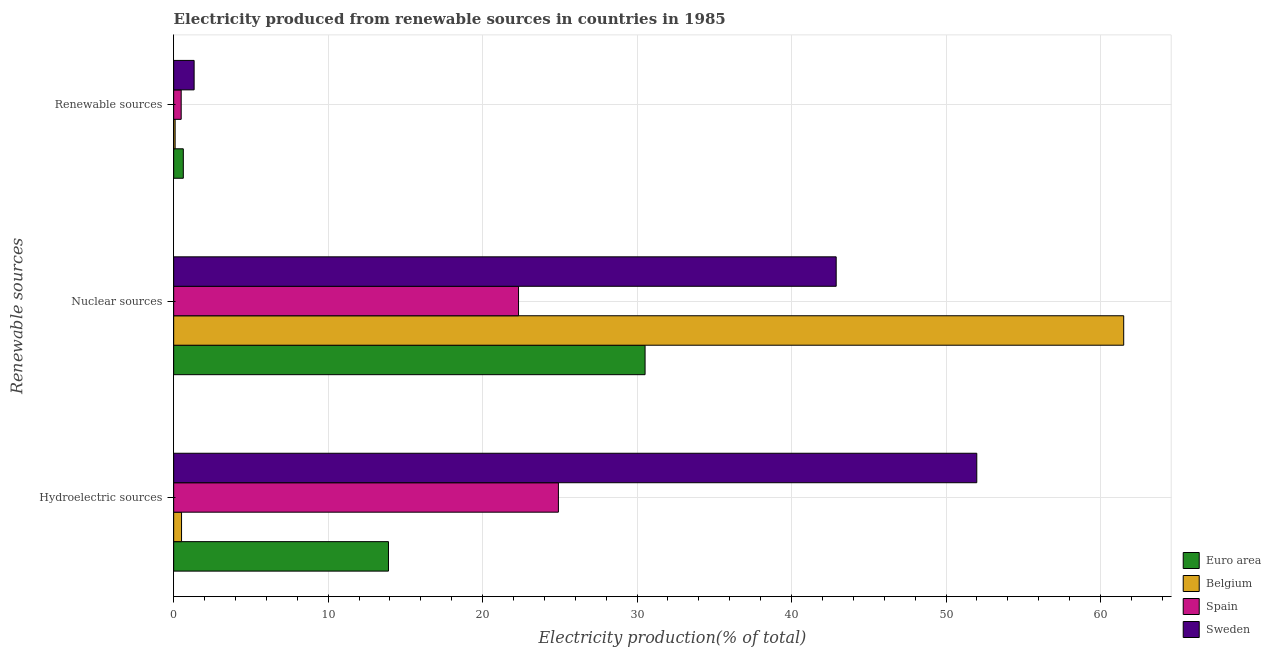Are the number of bars per tick equal to the number of legend labels?
Make the answer very short. Yes. What is the label of the 2nd group of bars from the top?
Keep it short and to the point. Nuclear sources. What is the percentage of electricity produced by renewable sources in Spain?
Provide a succinct answer. 0.49. Across all countries, what is the maximum percentage of electricity produced by nuclear sources?
Ensure brevity in your answer.  61.5. Across all countries, what is the minimum percentage of electricity produced by hydroelectric sources?
Give a very brief answer. 0.51. What is the total percentage of electricity produced by nuclear sources in the graph?
Offer a terse response. 157.23. What is the difference between the percentage of electricity produced by renewable sources in Spain and that in Belgium?
Your answer should be very brief. 0.39. What is the difference between the percentage of electricity produced by nuclear sources in Sweden and the percentage of electricity produced by hydroelectric sources in Spain?
Offer a very short reply. 17.98. What is the average percentage of electricity produced by hydroelectric sources per country?
Offer a terse response. 22.83. What is the difference between the percentage of electricity produced by hydroelectric sources and percentage of electricity produced by nuclear sources in Sweden?
Offer a terse response. 9.1. In how many countries, is the percentage of electricity produced by nuclear sources greater than 46 %?
Your answer should be very brief. 1. What is the ratio of the percentage of electricity produced by nuclear sources in Spain to that in Belgium?
Your answer should be compact. 0.36. Is the percentage of electricity produced by renewable sources in Spain less than that in Euro area?
Ensure brevity in your answer.  Yes. What is the difference between the highest and the second highest percentage of electricity produced by renewable sources?
Your answer should be compact. 0.7. What is the difference between the highest and the lowest percentage of electricity produced by hydroelectric sources?
Offer a terse response. 51.48. In how many countries, is the percentage of electricity produced by hydroelectric sources greater than the average percentage of electricity produced by hydroelectric sources taken over all countries?
Provide a short and direct response. 2. Is the sum of the percentage of electricity produced by hydroelectric sources in Spain and Belgium greater than the maximum percentage of electricity produced by renewable sources across all countries?
Offer a very short reply. Yes. What does the 3rd bar from the top in Nuclear sources represents?
Your response must be concise. Belgium. Is it the case that in every country, the sum of the percentage of electricity produced by hydroelectric sources and percentage of electricity produced by nuclear sources is greater than the percentage of electricity produced by renewable sources?
Offer a terse response. Yes. How many countries are there in the graph?
Your answer should be very brief. 4. Are the values on the major ticks of X-axis written in scientific E-notation?
Your answer should be compact. No. Does the graph contain grids?
Your answer should be very brief. Yes. What is the title of the graph?
Provide a succinct answer. Electricity produced from renewable sources in countries in 1985. What is the label or title of the Y-axis?
Ensure brevity in your answer.  Renewable sources. What is the Electricity production(% of total) in Euro area in Hydroelectric sources?
Keep it short and to the point. 13.91. What is the Electricity production(% of total) of Belgium in Hydroelectric sources?
Make the answer very short. 0.51. What is the Electricity production(% of total) in Spain in Hydroelectric sources?
Provide a short and direct response. 24.91. What is the Electricity production(% of total) of Sweden in Hydroelectric sources?
Your response must be concise. 51.99. What is the Electricity production(% of total) in Euro area in Nuclear sources?
Offer a very short reply. 30.52. What is the Electricity production(% of total) of Belgium in Nuclear sources?
Your answer should be compact. 61.5. What is the Electricity production(% of total) in Spain in Nuclear sources?
Your answer should be very brief. 22.33. What is the Electricity production(% of total) in Sweden in Nuclear sources?
Make the answer very short. 42.89. What is the Electricity production(% of total) of Euro area in Renewable sources?
Provide a succinct answer. 0.62. What is the Electricity production(% of total) in Belgium in Renewable sources?
Your answer should be very brief. 0.09. What is the Electricity production(% of total) of Spain in Renewable sources?
Provide a short and direct response. 0.49. What is the Electricity production(% of total) in Sweden in Renewable sources?
Give a very brief answer. 1.32. Across all Renewable sources, what is the maximum Electricity production(% of total) of Euro area?
Your response must be concise. 30.52. Across all Renewable sources, what is the maximum Electricity production(% of total) in Belgium?
Your response must be concise. 61.5. Across all Renewable sources, what is the maximum Electricity production(% of total) in Spain?
Make the answer very short. 24.91. Across all Renewable sources, what is the maximum Electricity production(% of total) in Sweden?
Your answer should be very brief. 51.99. Across all Renewable sources, what is the minimum Electricity production(% of total) of Euro area?
Provide a short and direct response. 0.62. Across all Renewable sources, what is the minimum Electricity production(% of total) in Belgium?
Make the answer very short. 0.09. Across all Renewable sources, what is the minimum Electricity production(% of total) in Spain?
Provide a succinct answer. 0.49. Across all Renewable sources, what is the minimum Electricity production(% of total) in Sweden?
Ensure brevity in your answer.  1.32. What is the total Electricity production(% of total) in Euro area in the graph?
Your response must be concise. 45.05. What is the total Electricity production(% of total) in Belgium in the graph?
Make the answer very short. 62.11. What is the total Electricity production(% of total) of Spain in the graph?
Make the answer very short. 47.72. What is the total Electricity production(% of total) of Sweden in the graph?
Keep it short and to the point. 96.2. What is the difference between the Electricity production(% of total) in Euro area in Hydroelectric sources and that in Nuclear sources?
Offer a very short reply. -16.61. What is the difference between the Electricity production(% of total) in Belgium in Hydroelectric sources and that in Nuclear sources?
Ensure brevity in your answer.  -60.99. What is the difference between the Electricity production(% of total) of Spain in Hydroelectric sources and that in Nuclear sources?
Your answer should be compact. 2.58. What is the difference between the Electricity production(% of total) in Sweden in Hydroelectric sources and that in Nuclear sources?
Offer a terse response. 9.1. What is the difference between the Electricity production(% of total) of Euro area in Hydroelectric sources and that in Renewable sources?
Make the answer very short. 13.28. What is the difference between the Electricity production(% of total) of Belgium in Hydroelectric sources and that in Renewable sources?
Your answer should be very brief. 0.42. What is the difference between the Electricity production(% of total) in Spain in Hydroelectric sources and that in Renewable sources?
Your answer should be compact. 24.42. What is the difference between the Electricity production(% of total) in Sweden in Hydroelectric sources and that in Renewable sources?
Your answer should be very brief. 50.67. What is the difference between the Electricity production(% of total) of Euro area in Nuclear sources and that in Renewable sources?
Make the answer very short. 29.89. What is the difference between the Electricity production(% of total) in Belgium in Nuclear sources and that in Renewable sources?
Your answer should be compact. 61.41. What is the difference between the Electricity production(% of total) of Spain in Nuclear sources and that in Renewable sources?
Give a very brief answer. 21.84. What is the difference between the Electricity production(% of total) in Sweden in Nuclear sources and that in Renewable sources?
Provide a short and direct response. 41.57. What is the difference between the Electricity production(% of total) of Euro area in Hydroelectric sources and the Electricity production(% of total) of Belgium in Nuclear sources?
Your response must be concise. -47.6. What is the difference between the Electricity production(% of total) in Euro area in Hydroelectric sources and the Electricity production(% of total) in Spain in Nuclear sources?
Your answer should be compact. -8.42. What is the difference between the Electricity production(% of total) in Euro area in Hydroelectric sources and the Electricity production(% of total) in Sweden in Nuclear sources?
Give a very brief answer. -28.98. What is the difference between the Electricity production(% of total) of Belgium in Hydroelectric sources and the Electricity production(% of total) of Spain in Nuclear sources?
Ensure brevity in your answer.  -21.81. What is the difference between the Electricity production(% of total) of Belgium in Hydroelectric sources and the Electricity production(% of total) of Sweden in Nuclear sources?
Provide a short and direct response. -42.38. What is the difference between the Electricity production(% of total) in Spain in Hydroelectric sources and the Electricity production(% of total) in Sweden in Nuclear sources?
Offer a terse response. -17.98. What is the difference between the Electricity production(% of total) in Euro area in Hydroelectric sources and the Electricity production(% of total) in Belgium in Renewable sources?
Your answer should be very brief. 13.81. What is the difference between the Electricity production(% of total) in Euro area in Hydroelectric sources and the Electricity production(% of total) in Spain in Renewable sources?
Keep it short and to the point. 13.42. What is the difference between the Electricity production(% of total) in Euro area in Hydroelectric sources and the Electricity production(% of total) in Sweden in Renewable sources?
Ensure brevity in your answer.  12.58. What is the difference between the Electricity production(% of total) of Belgium in Hydroelectric sources and the Electricity production(% of total) of Spain in Renewable sources?
Ensure brevity in your answer.  0.02. What is the difference between the Electricity production(% of total) of Belgium in Hydroelectric sources and the Electricity production(% of total) of Sweden in Renewable sources?
Your answer should be compact. -0.81. What is the difference between the Electricity production(% of total) in Spain in Hydroelectric sources and the Electricity production(% of total) in Sweden in Renewable sources?
Your response must be concise. 23.58. What is the difference between the Electricity production(% of total) of Euro area in Nuclear sources and the Electricity production(% of total) of Belgium in Renewable sources?
Offer a terse response. 30.42. What is the difference between the Electricity production(% of total) of Euro area in Nuclear sources and the Electricity production(% of total) of Spain in Renewable sources?
Ensure brevity in your answer.  30.03. What is the difference between the Electricity production(% of total) in Euro area in Nuclear sources and the Electricity production(% of total) in Sweden in Renewable sources?
Offer a terse response. 29.19. What is the difference between the Electricity production(% of total) of Belgium in Nuclear sources and the Electricity production(% of total) of Spain in Renewable sources?
Ensure brevity in your answer.  61.02. What is the difference between the Electricity production(% of total) in Belgium in Nuclear sources and the Electricity production(% of total) in Sweden in Renewable sources?
Ensure brevity in your answer.  60.18. What is the difference between the Electricity production(% of total) in Spain in Nuclear sources and the Electricity production(% of total) in Sweden in Renewable sources?
Keep it short and to the point. 21. What is the average Electricity production(% of total) in Euro area per Renewable sources?
Give a very brief answer. 15.02. What is the average Electricity production(% of total) in Belgium per Renewable sources?
Ensure brevity in your answer.  20.7. What is the average Electricity production(% of total) of Spain per Renewable sources?
Provide a succinct answer. 15.91. What is the average Electricity production(% of total) of Sweden per Renewable sources?
Provide a succinct answer. 32.07. What is the difference between the Electricity production(% of total) of Euro area and Electricity production(% of total) of Belgium in Hydroelectric sources?
Your response must be concise. 13.39. What is the difference between the Electricity production(% of total) in Euro area and Electricity production(% of total) in Spain in Hydroelectric sources?
Give a very brief answer. -11. What is the difference between the Electricity production(% of total) of Euro area and Electricity production(% of total) of Sweden in Hydroelectric sources?
Keep it short and to the point. -38.09. What is the difference between the Electricity production(% of total) in Belgium and Electricity production(% of total) in Spain in Hydroelectric sources?
Give a very brief answer. -24.4. What is the difference between the Electricity production(% of total) in Belgium and Electricity production(% of total) in Sweden in Hydroelectric sources?
Your response must be concise. -51.48. What is the difference between the Electricity production(% of total) in Spain and Electricity production(% of total) in Sweden in Hydroelectric sources?
Provide a succinct answer. -27.08. What is the difference between the Electricity production(% of total) in Euro area and Electricity production(% of total) in Belgium in Nuclear sources?
Your answer should be very brief. -30.99. What is the difference between the Electricity production(% of total) of Euro area and Electricity production(% of total) of Spain in Nuclear sources?
Your answer should be very brief. 8.19. What is the difference between the Electricity production(% of total) of Euro area and Electricity production(% of total) of Sweden in Nuclear sources?
Offer a terse response. -12.37. What is the difference between the Electricity production(% of total) of Belgium and Electricity production(% of total) of Spain in Nuclear sources?
Provide a succinct answer. 39.18. What is the difference between the Electricity production(% of total) in Belgium and Electricity production(% of total) in Sweden in Nuclear sources?
Make the answer very short. 18.61. What is the difference between the Electricity production(% of total) in Spain and Electricity production(% of total) in Sweden in Nuclear sources?
Your answer should be very brief. -20.56. What is the difference between the Electricity production(% of total) in Euro area and Electricity production(% of total) in Belgium in Renewable sources?
Offer a terse response. 0.53. What is the difference between the Electricity production(% of total) of Euro area and Electricity production(% of total) of Spain in Renewable sources?
Your answer should be compact. 0.14. What is the difference between the Electricity production(% of total) of Euro area and Electricity production(% of total) of Sweden in Renewable sources?
Provide a short and direct response. -0.7. What is the difference between the Electricity production(% of total) in Belgium and Electricity production(% of total) in Spain in Renewable sources?
Give a very brief answer. -0.39. What is the difference between the Electricity production(% of total) of Belgium and Electricity production(% of total) of Sweden in Renewable sources?
Keep it short and to the point. -1.23. What is the difference between the Electricity production(% of total) in Spain and Electricity production(% of total) in Sweden in Renewable sources?
Offer a terse response. -0.84. What is the ratio of the Electricity production(% of total) of Euro area in Hydroelectric sources to that in Nuclear sources?
Keep it short and to the point. 0.46. What is the ratio of the Electricity production(% of total) of Belgium in Hydroelectric sources to that in Nuclear sources?
Ensure brevity in your answer.  0.01. What is the ratio of the Electricity production(% of total) in Spain in Hydroelectric sources to that in Nuclear sources?
Provide a succinct answer. 1.12. What is the ratio of the Electricity production(% of total) of Sweden in Hydroelectric sources to that in Nuclear sources?
Ensure brevity in your answer.  1.21. What is the ratio of the Electricity production(% of total) of Euro area in Hydroelectric sources to that in Renewable sources?
Your answer should be very brief. 22.27. What is the ratio of the Electricity production(% of total) of Belgium in Hydroelectric sources to that in Renewable sources?
Make the answer very short. 5.42. What is the ratio of the Electricity production(% of total) of Spain in Hydroelectric sources to that in Renewable sources?
Offer a very short reply. 51.21. What is the ratio of the Electricity production(% of total) of Sweden in Hydroelectric sources to that in Renewable sources?
Keep it short and to the point. 39.26. What is the ratio of the Electricity production(% of total) of Euro area in Nuclear sources to that in Renewable sources?
Your answer should be compact. 48.88. What is the ratio of the Electricity production(% of total) of Belgium in Nuclear sources to that in Renewable sources?
Offer a terse response. 652.85. What is the ratio of the Electricity production(% of total) of Spain in Nuclear sources to that in Renewable sources?
Offer a very short reply. 45.9. What is the ratio of the Electricity production(% of total) in Sweden in Nuclear sources to that in Renewable sources?
Give a very brief answer. 32.39. What is the difference between the highest and the second highest Electricity production(% of total) in Euro area?
Offer a very short reply. 16.61. What is the difference between the highest and the second highest Electricity production(% of total) in Belgium?
Offer a very short reply. 60.99. What is the difference between the highest and the second highest Electricity production(% of total) of Spain?
Provide a short and direct response. 2.58. What is the difference between the highest and the second highest Electricity production(% of total) in Sweden?
Provide a short and direct response. 9.1. What is the difference between the highest and the lowest Electricity production(% of total) in Euro area?
Give a very brief answer. 29.89. What is the difference between the highest and the lowest Electricity production(% of total) in Belgium?
Make the answer very short. 61.41. What is the difference between the highest and the lowest Electricity production(% of total) of Spain?
Provide a short and direct response. 24.42. What is the difference between the highest and the lowest Electricity production(% of total) of Sweden?
Your answer should be compact. 50.67. 